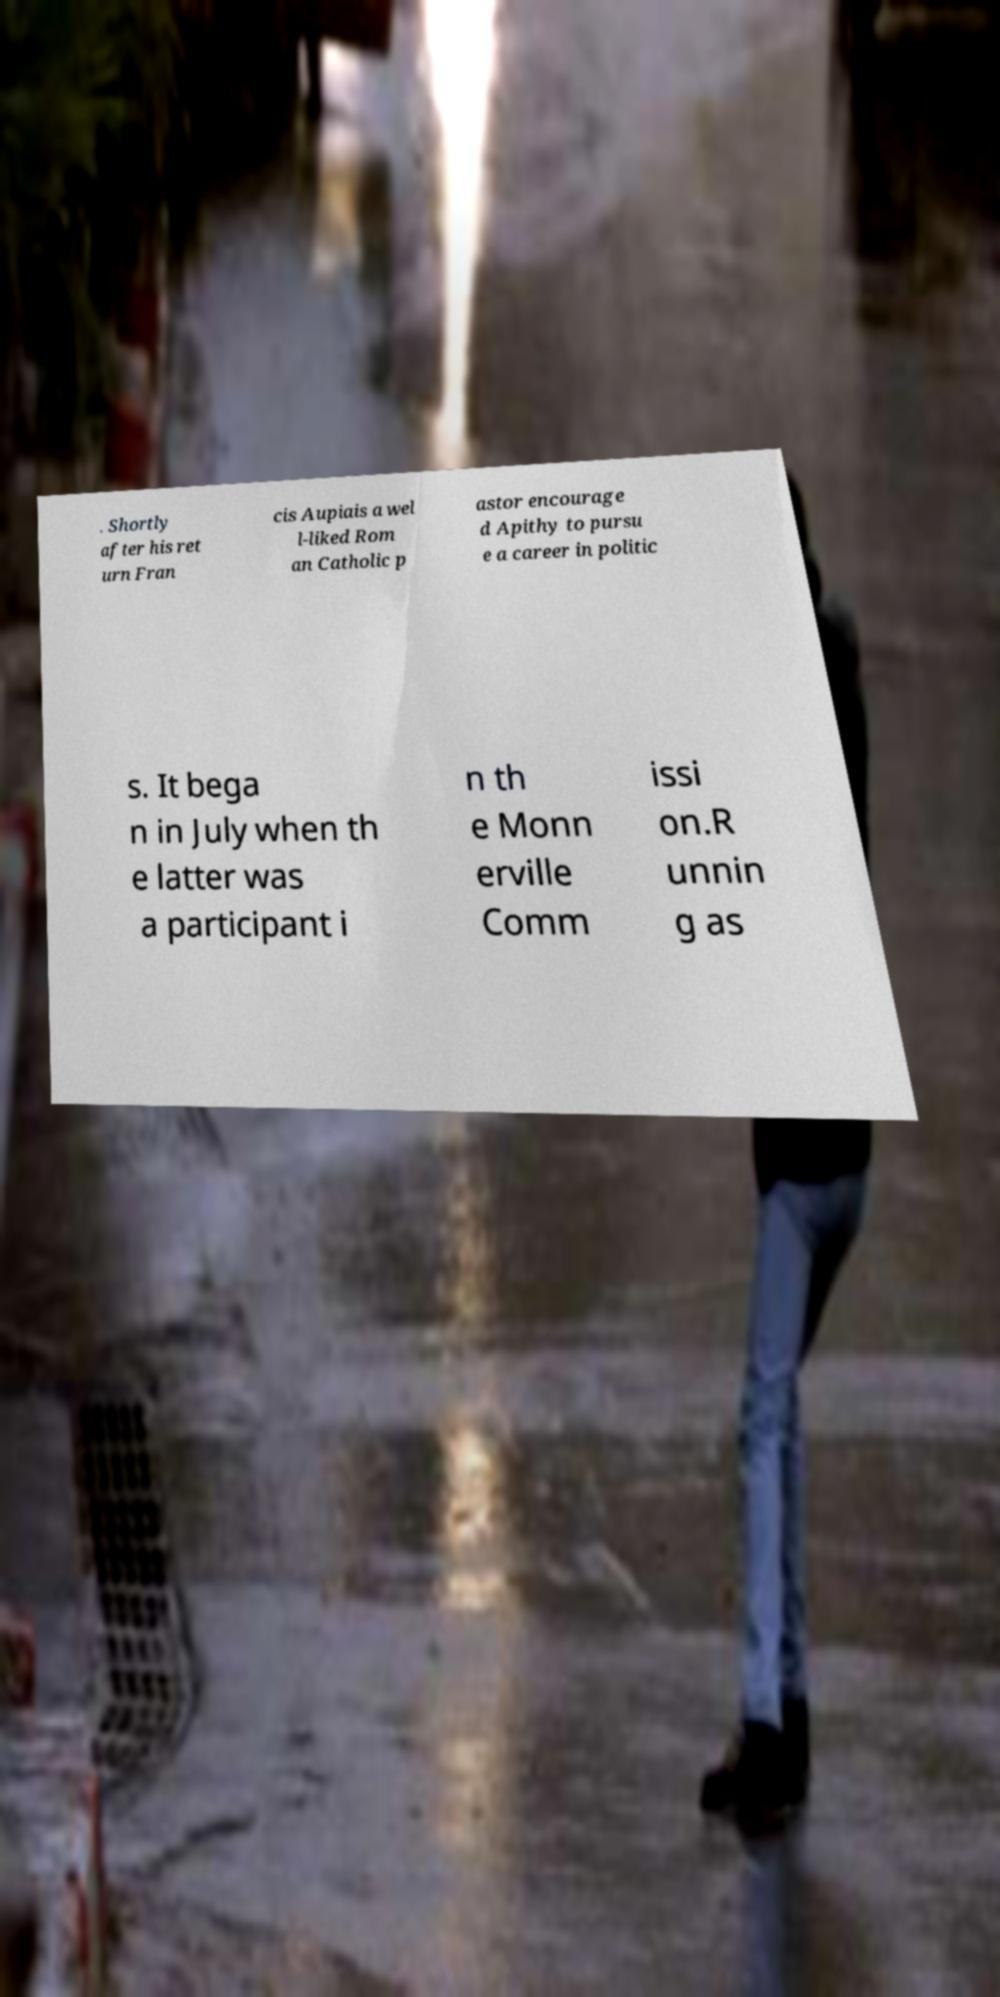Can you read and provide the text displayed in the image?This photo seems to have some interesting text. Can you extract and type it out for me? . Shortly after his ret urn Fran cis Aupiais a wel l-liked Rom an Catholic p astor encourage d Apithy to pursu e a career in politic s. It bega n in July when th e latter was a participant i n th e Monn erville Comm issi on.R unnin g as 